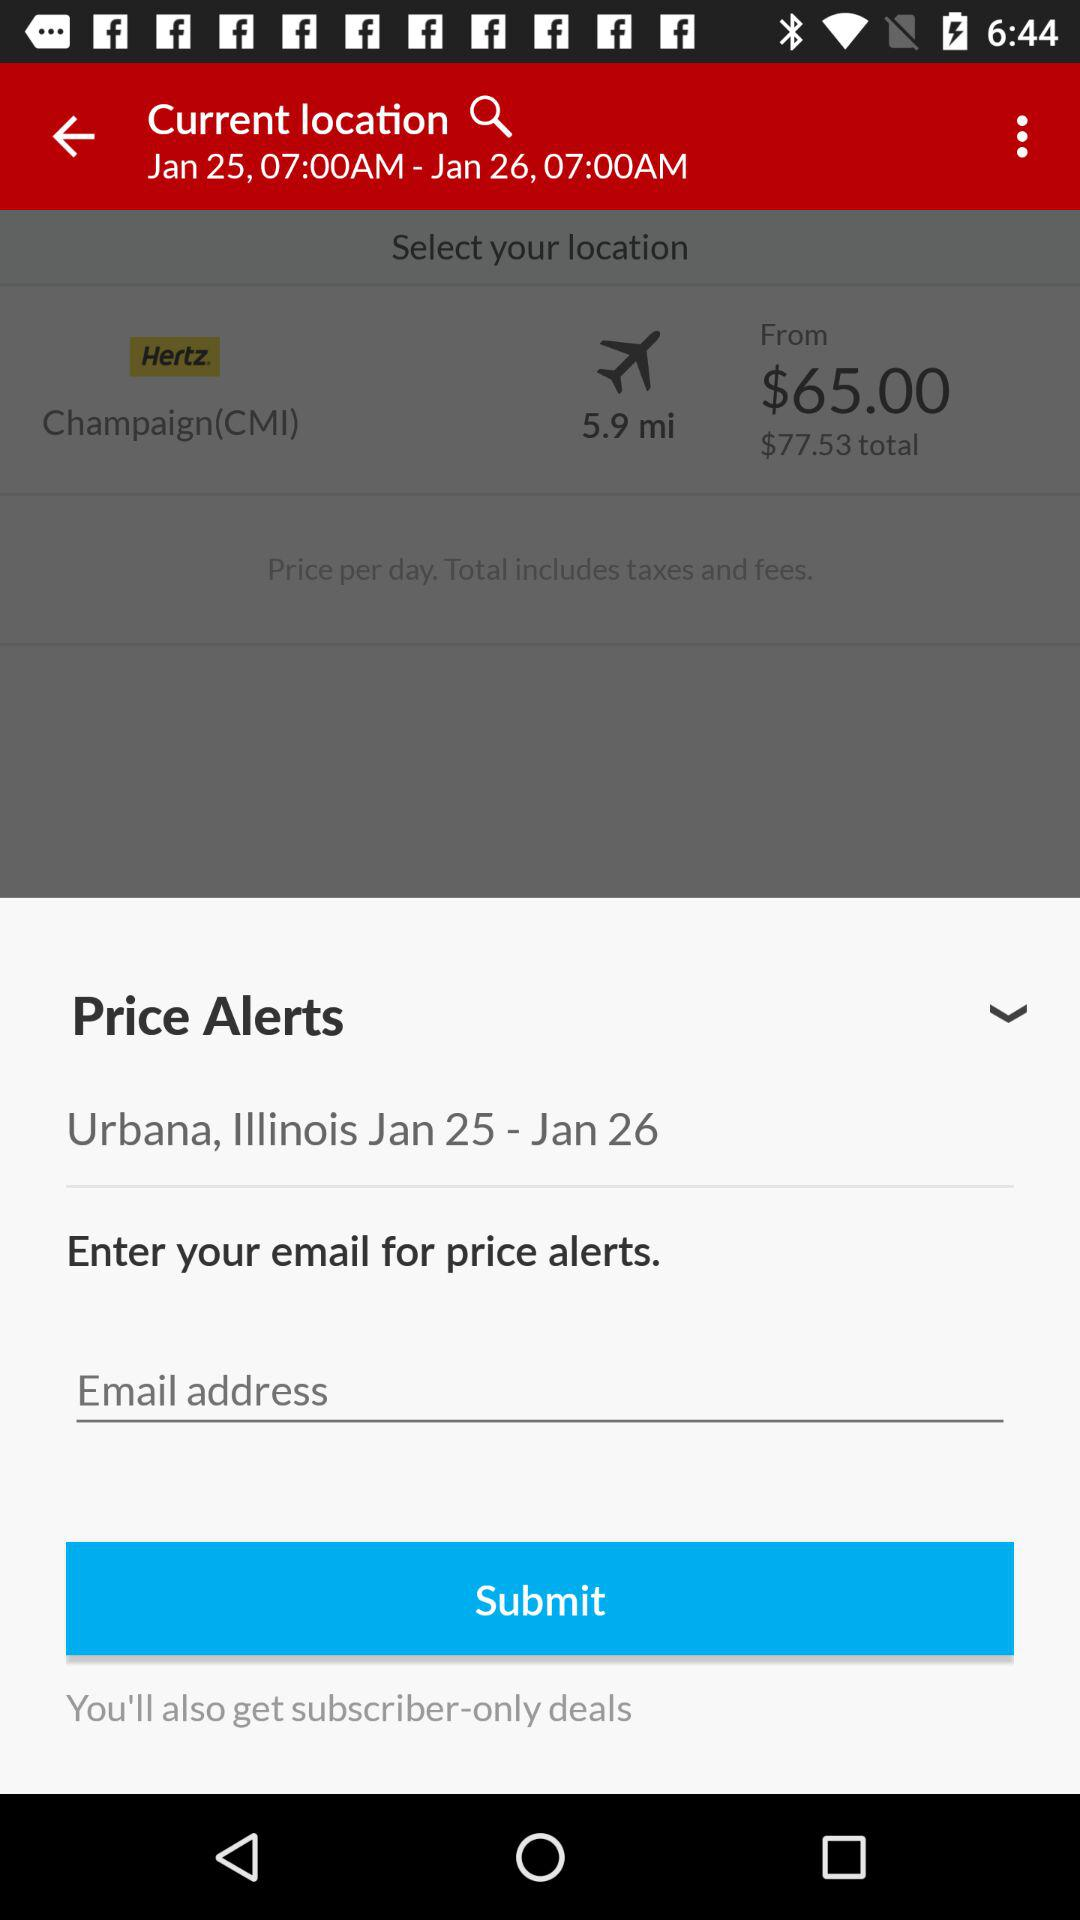What is the total price? The total price is $77.53. 